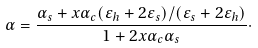<formula> <loc_0><loc_0><loc_500><loc_500>\alpha = \frac { \alpha _ { s } + x \alpha _ { c } ( \varepsilon _ { h } + 2 \varepsilon _ { s } ) / ( \varepsilon _ { s } + 2 \varepsilon _ { h } ) } { 1 + 2 x \alpha _ { c } \alpha _ { s } } \cdot</formula> 